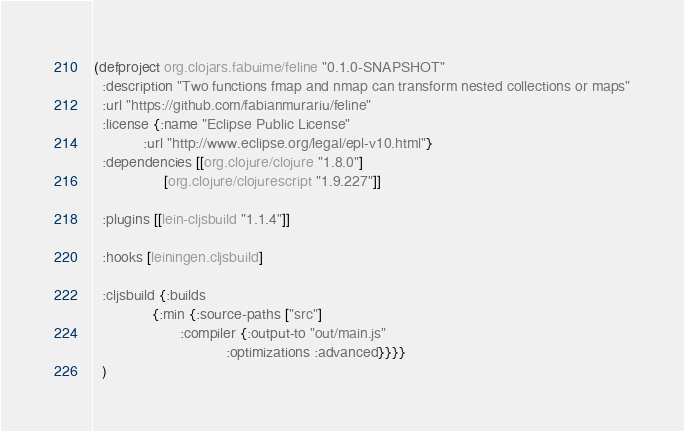<code> <loc_0><loc_0><loc_500><loc_500><_Clojure_>(defproject org.clojars.fabuime/feline "0.1.0-SNAPSHOT"
  :description "Two functions fmap and nmap can transform nested collections or maps"
  :url "https://github.com/fabianmurariu/feline"
  :license {:name "Eclipse Public License"
            :url "http://www.eclipse.org/legal/epl-v10.html"}
  :dependencies [[org.clojure/clojure "1.8.0"]
                 [org.clojure/clojurescript "1.9.227"]]

  :plugins [[lein-cljsbuild "1.1.4"]]

  :hooks [leiningen.cljsbuild]

  :cljsbuild {:builds
              {:min {:source-paths ["src"]
                     :compiler {:output-to "out/main.js"
                                :optimizations :advanced}}}}
  )
</code> 